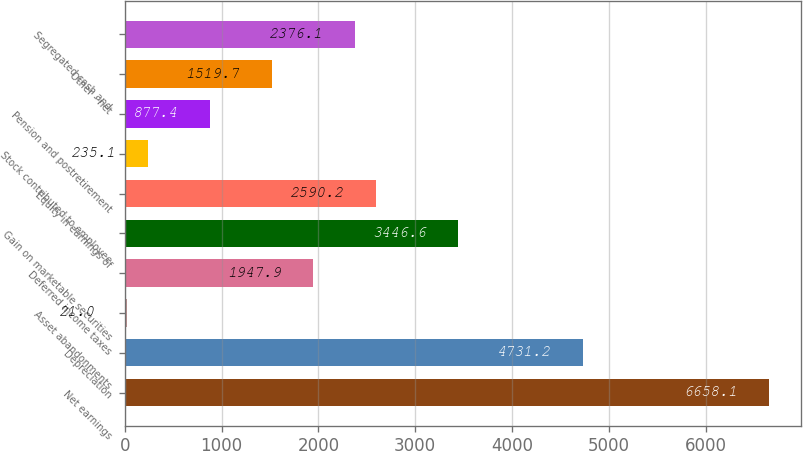Convert chart. <chart><loc_0><loc_0><loc_500><loc_500><bar_chart><fcel>Net earnings<fcel>Depreciation<fcel>Asset abandonments<fcel>Deferred income taxes<fcel>Gain on marketable securities<fcel>Equity in earnings of<fcel>Stock contributed to employee<fcel>Pension and postretirement<fcel>Other - net<fcel>Segregated cash and<nl><fcel>6658.1<fcel>4731.2<fcel>21<fcel>1947.9<fcel>3446.6<fcel>2590.2<fcel>235.1<fcel>877.4<fcel>1519.7<fcel>2376.1<nl></chart> 